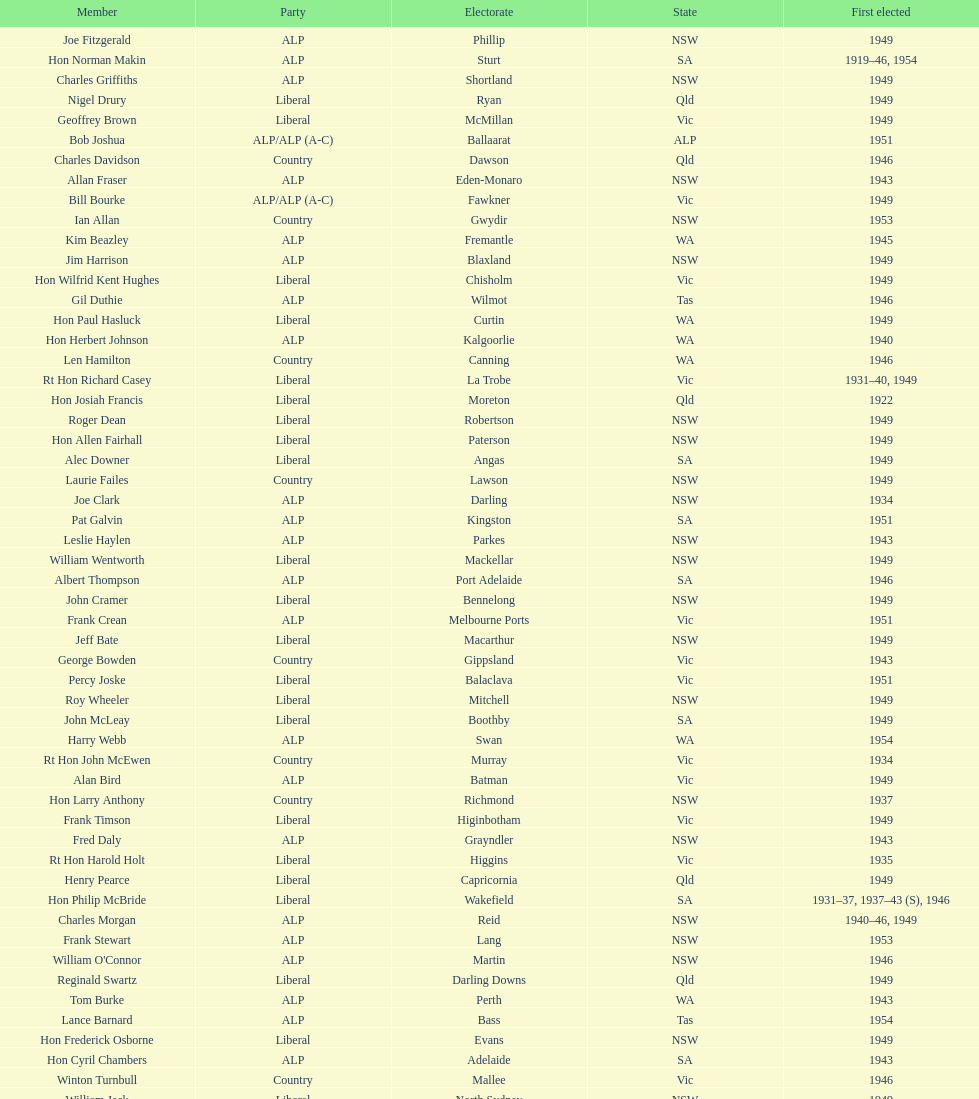Which party was elected the least? Country. 